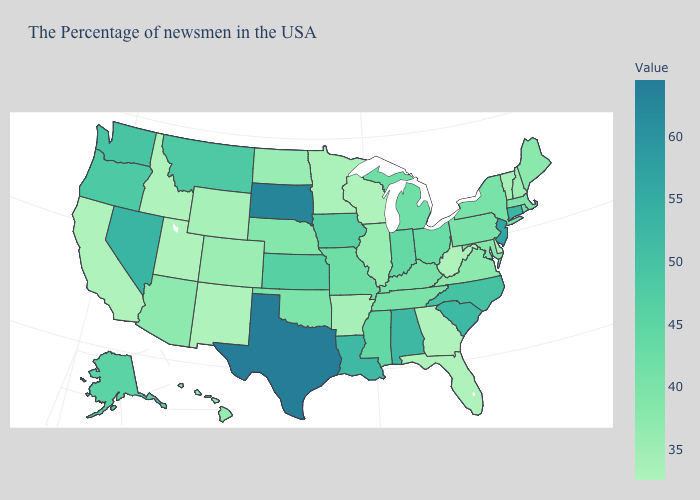Which states have the highest value in the USA?
Short answer required. Texas. Is the legend a continuous bar?
Write a very short answer. Yes. Which states have the highest value in the USA?
Short answer required. Texas. Is the legend a continuous bar?
Concise answer only. Yes. Is the legend a continuous bar?
Keep it brief. Yes. Does Texas have the highest value in the USA?
Write a very short answer. Yes. 